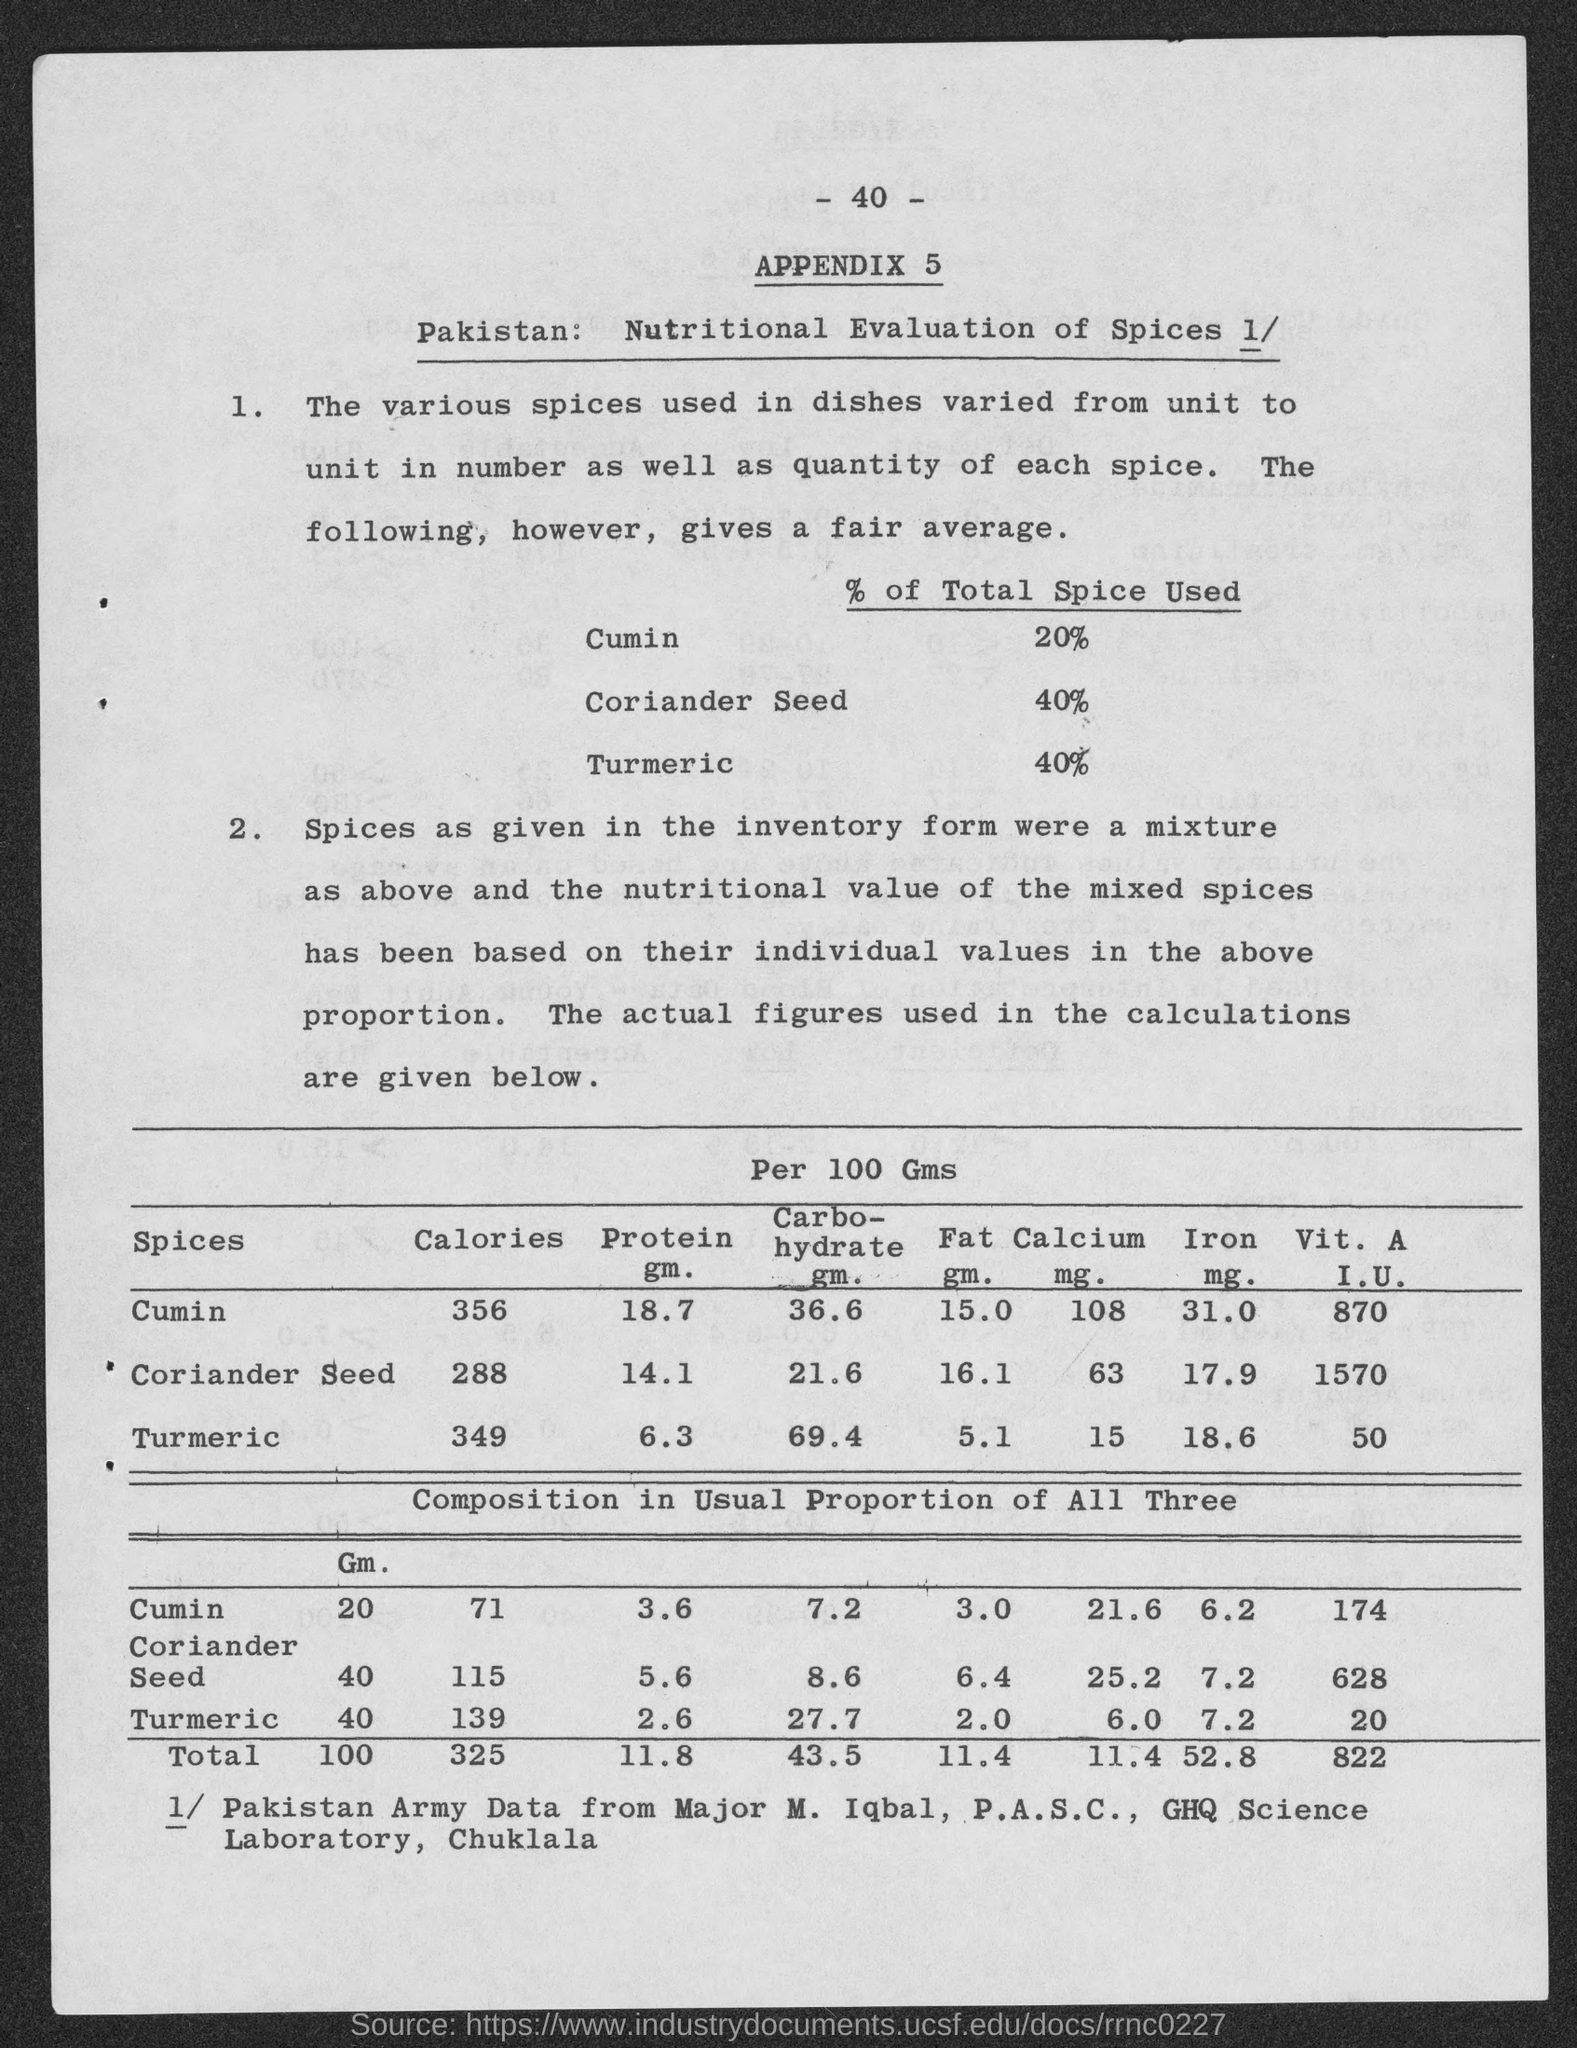Can you tell me more about the contents of the page in the image? The image features a document titled 'APPENDIX 5', detailing a nutritional evaluation of spices from Pakistan. The top section summarizes the percentage of total spice used in dishes, listing cumin, coriander seed, and turmeric. The lower section presents a table with nutritional information per 100 grams for these spices, including calorie content, protein, carbohydrates, fat, calcium, iron, and vitamin A levels. Additionally, there's a composition breakdown, showing the usual proportions of these spices when mixed. 